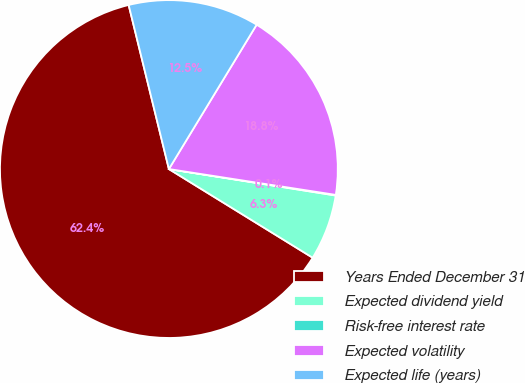<chart> <loc_0><loc_0><loc_500><loc_500><pie_chart><fcel>Years Ended December 31<fcel>Expected dividend yield<fcel>Risk-free interest rate<fcel>Expected volatility<fcel>Expected life (years)<nl><fcel>62.37%<fcel>6.29%<fcel>0.06%<fcel>18.75%<fcel>12.52%<nl></chart> 